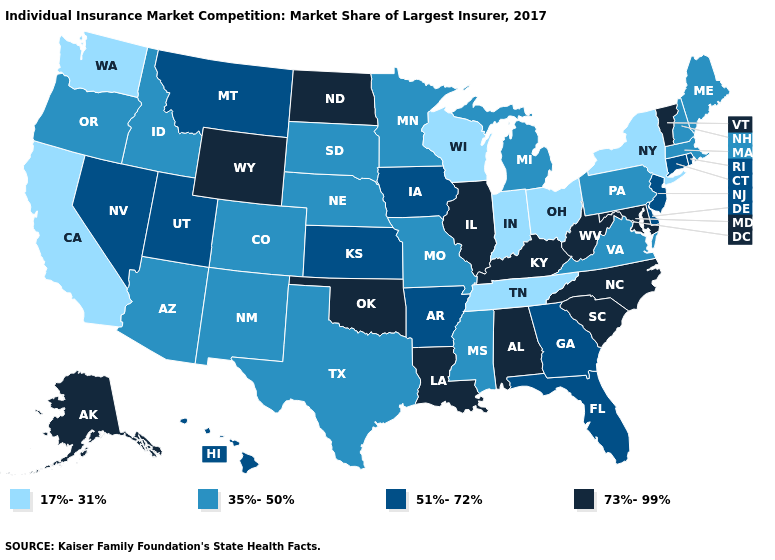Does the map have missing data?
Be succinct. No. Does Indiana have the lowest value in the MidWest?
Answer briefly. Yes. Name the states that have a value in the range 51%-72%?
Short answer required. Arkansas, Connecticut, Delaware, Florida, Georgia, Hawaii, Iowa, Kansas, Montana, Nevada, New Jersey, Rhode Island, Utah. What is the value of Washington?
Short answer required. 17%-31%. Does Idaho have the highest value in the West?
Write a very short answer. No. What is the highest value in states that border Oregon?
Write a very short answer. 51%-72%. Does South Dakota have a lower value than Michigan?
Short answer required. No. Which states have the highest value in the USA?
Give a very brief answer. Alabama, Alaska, Illinois, Kentucky, Louisiana, Maryland, North Carolina, North Dakota, Oklahoma, South Carolina, Vermont, West Virginia, Wyoming. Which states have the highest value in the USA?
Short answer required. Alabama, Alaska, Illinois, Kentucky, Louisiana, Maryland, North Carolina, North Dakota, Oklahoma, South Carolina, Vermont, West Virginia, Wyoming. Which states hav the highest value in the Northeast?
Answer briefly. Vermont. Does Tennessee have a higher value than Alabama?
Be succinct. No. What is the highest value in the Northeast ?
Answer briefly. 73%-99%. Does Connecticut have the highest value in the Northeast?
Quick response, please. No. What is the value of Georgia?
Answer briefly. 51%-72%. Which states hav the highest value in the MidWest?
Be succinct. Illinois, North Dakota. 